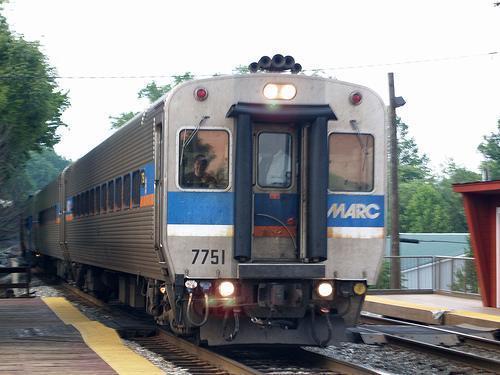How many numbers are on the train?
Give a very brief answer. 4. 